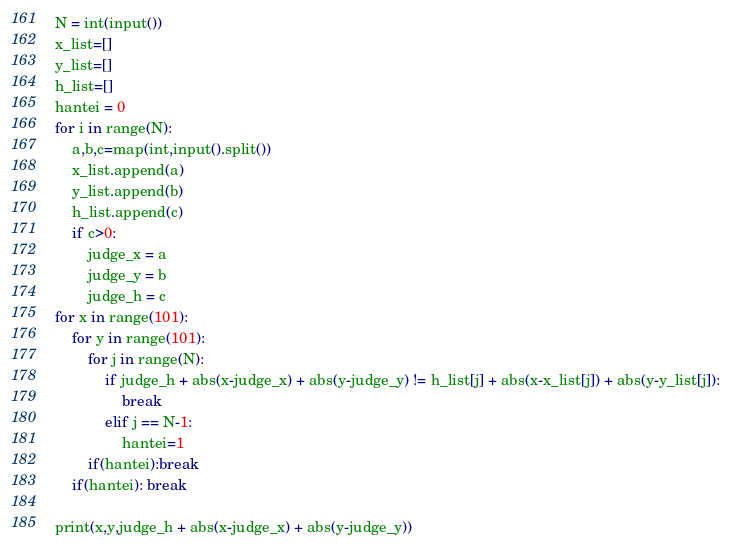Convert code to text. <code><loc_0><loc_0><loc_500><loc_500><_Python_>N = int(input())
x_list=[]
y_list=[]
h_list=[]
hantei = 0
for i in range(N):
    a,b,c=map(int,input().split())
    x_list.append(a)
    y_list.append(b)
    h_list.append(c)
    if c>0: 
        judge_x = a
        judge_y = b
        judge_h = c
for x in range(101):
    for y in range(101):
        for j in range(N):
            if judge_h + abs(x-judge_x) + abs(y-judge_y) != h_list[j] + abs(x-x_list[j]) + abs(y-y_list[j]):
                break
            elif j == N-1:
                hantei=1
        if(hantei):break
    if(hantei): break

print(x,y,judge_h + abs(x-judge_x) + abs(y-judge_y))</code> 